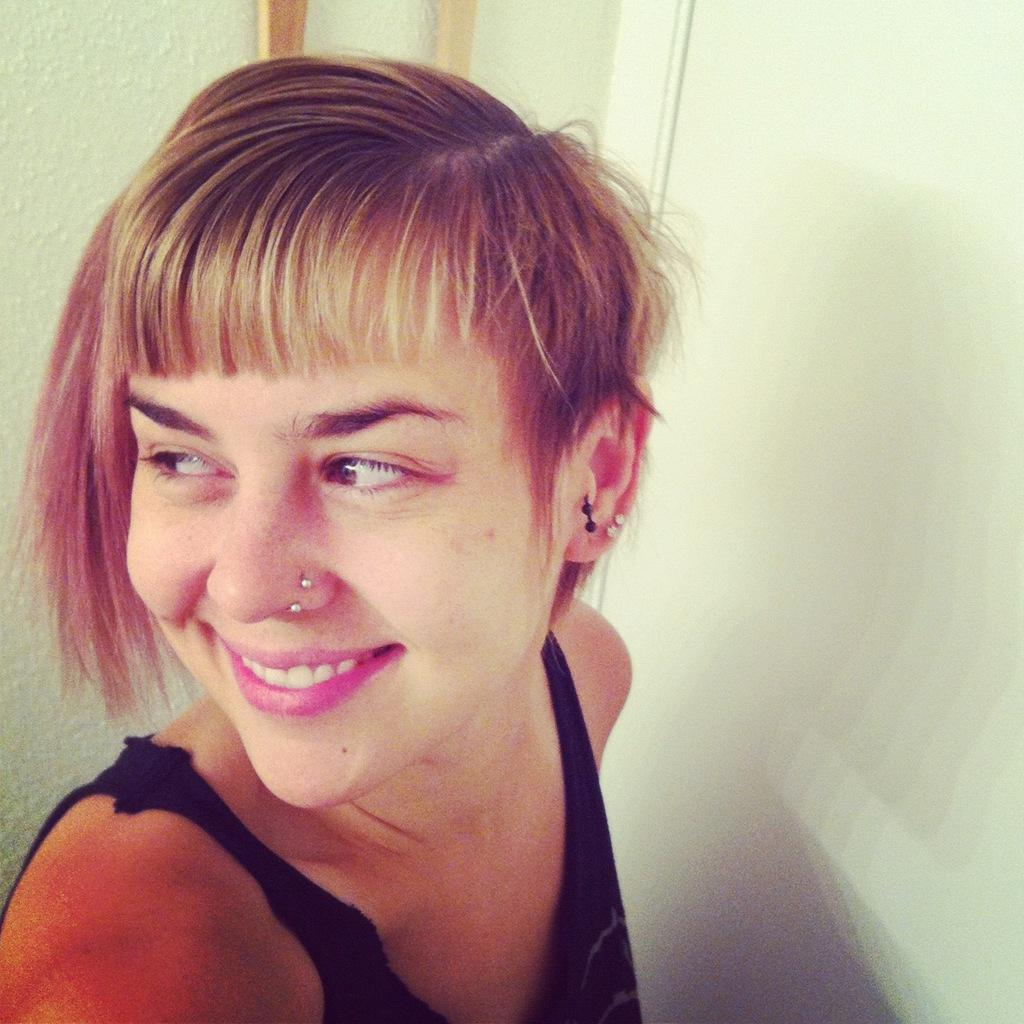Who is present in the image? There is a woman in the image. What is the woman's facial expression? The woman is smiling. What can be seen in the background of the image? There is a wall in the background of the image. What type of beetle can be seen crawling on the wall in the image? There is no beetle present in the image; only the woman and the wall are visible. 